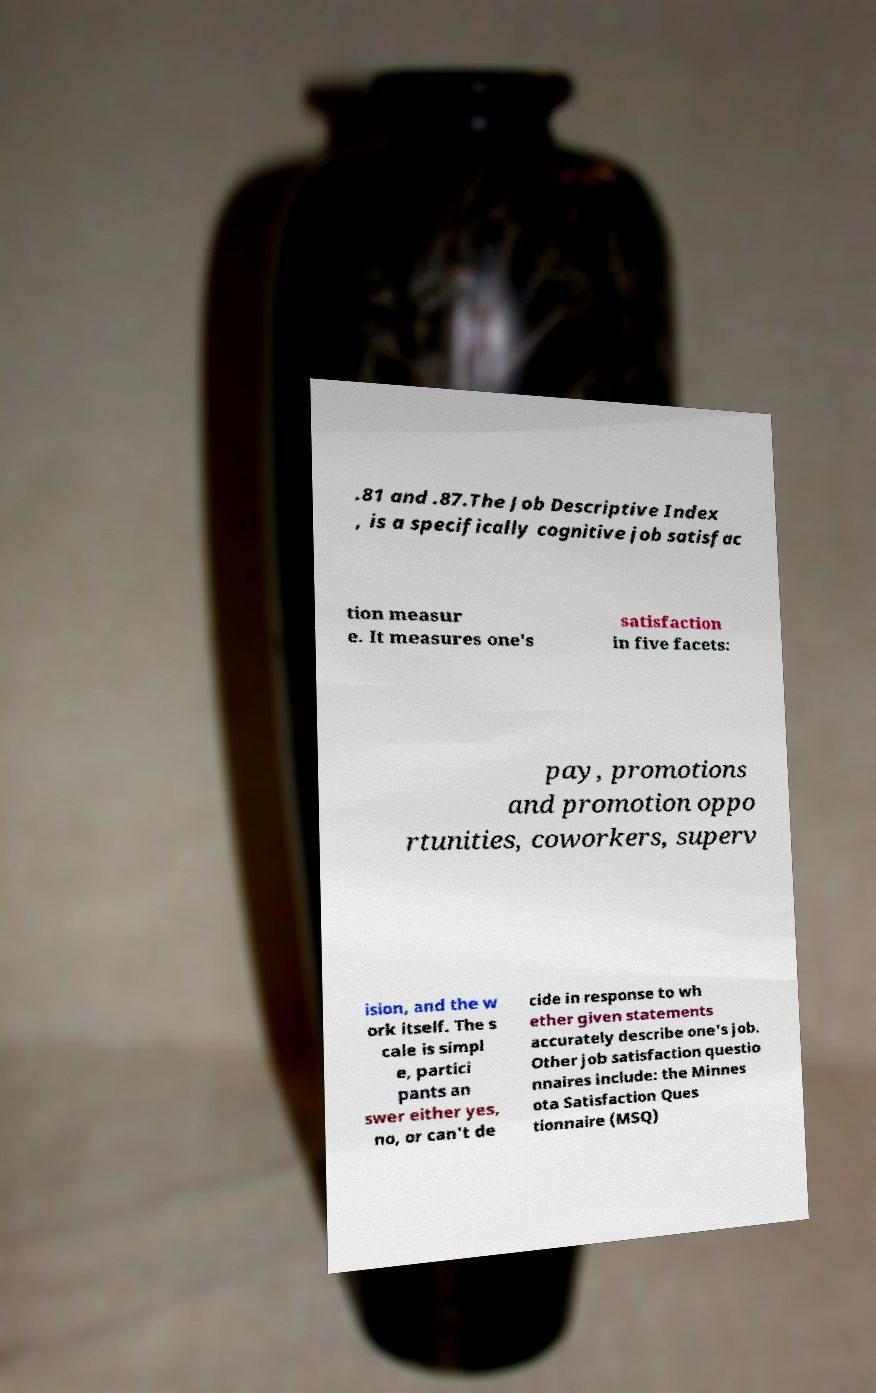Can you accurately transcribe the text from the provided image for me? .81 and .87.The Job Descriptive Index , is a specifically cognitive job satisfac tion measur e. It measures one's satisfaction in five facets: pay, promotions and promotion oppo rtunities, coworkers, superv ision, and the w ork itself. The s cale is simpl e, partici pants an swer either yes, no, or can't de cide in response to wh ether given statements accurately describe one's job. Other job satisfaction questio nnaires include: the Minnes ota Satisfaction Ques tionnaire (MSQ) 